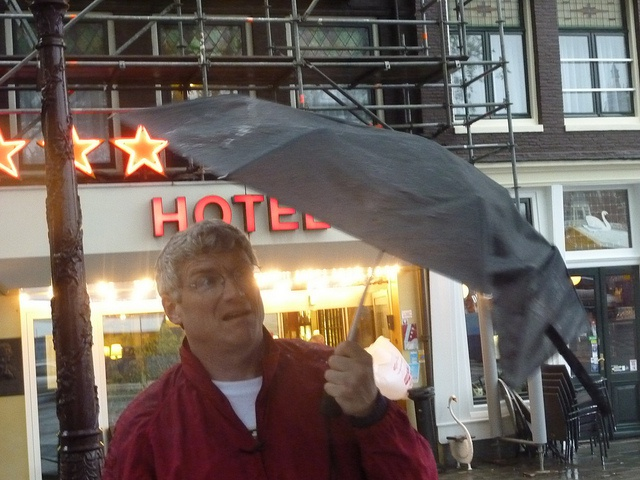Describe the objects in this image and their specific colors. I can see people in black, maroon, brown, and gray tones, umbrella in black and gray tones, chair in black, gray, and darkgray tones, bird in black, gray, darkgray, and lightgray tones, and chair in black, gray, and purple tones in this image. 